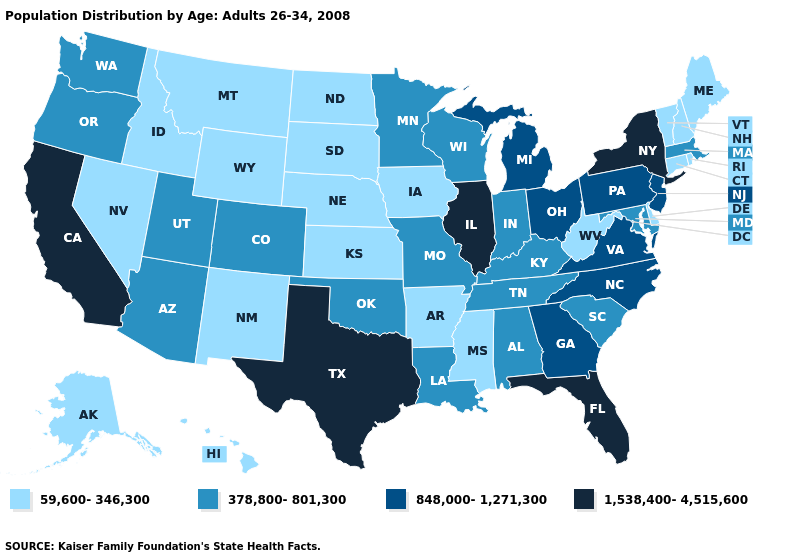What is the value of Arkansas?
Write a very short answer. 59,600-346,300. Name the states that have a value in the range 848,000-1,271,300?
Quick response, please. Georgia, Michigan, New Jersey, North Carolina, Ohio, Pennsylvania, Virginia. What is the value of Florida?
Give a very brief answer. 1,538,400-4,515,600. What is the highest value in the USA?
Write a very short answer. 1,538,400-4,515,600. Which states have the highest value in the USA?
Keep it brief. California, Florida, Illinois, New York, Texas. Which states have the highest value in the USA?
Keep it brief. California, Florida, Illinois, New York, Texas. Among the states that border Louisiana , which have the highest value?
Keep it brief. Texas. Does New York have the highest value in the USA?
Short answer required. Yes. Name the states that have a value in the range 59,600-346,300?
Keep it brief. Alaska, Arkansas, Connecticut, Delaware, Hawaii, Idaho, Iowa, Kansas, Maine, Mississippi, Montana, Nebraska, Nevada, New Hampshire, New Mexico, North Dakota, Rhode Island, South Dakota, Vermont, West Virginia, Wyoming. What is the value of Missouri?
Quick response, please. 378,800-801,300. What is the highest value in the USA?
Answer briefly. 1,538,400-4,515,600. What is the value of North Carolina?
Give a very brief answer. 848,000-1,271,300. What is the lowest value in the USA?
Answer briefly. 59,600-346,300. What is the value of California?
Be succinct. 1,538,400-4,515,600. What is the value of Virginia?
Quick response, please. 848,000-1,271,300. 